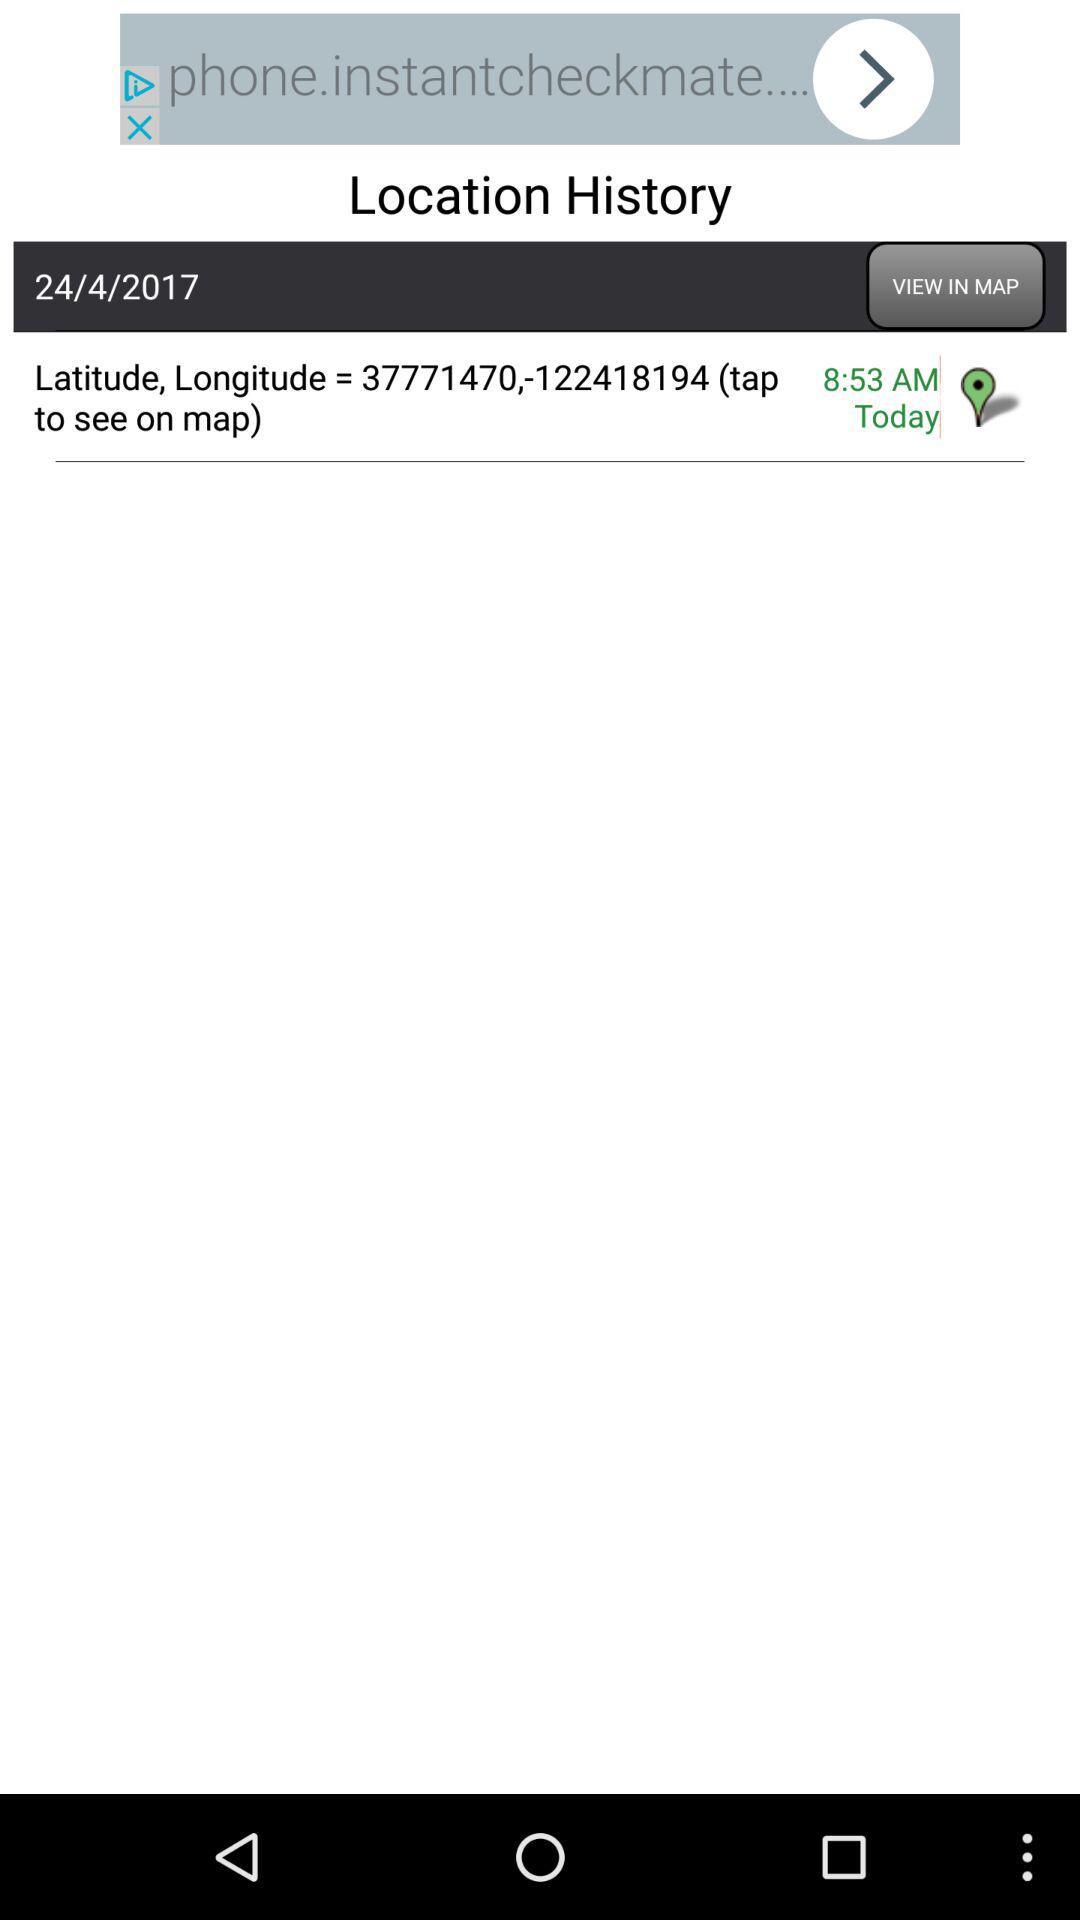What is the date? The date is April 24, 2017. 